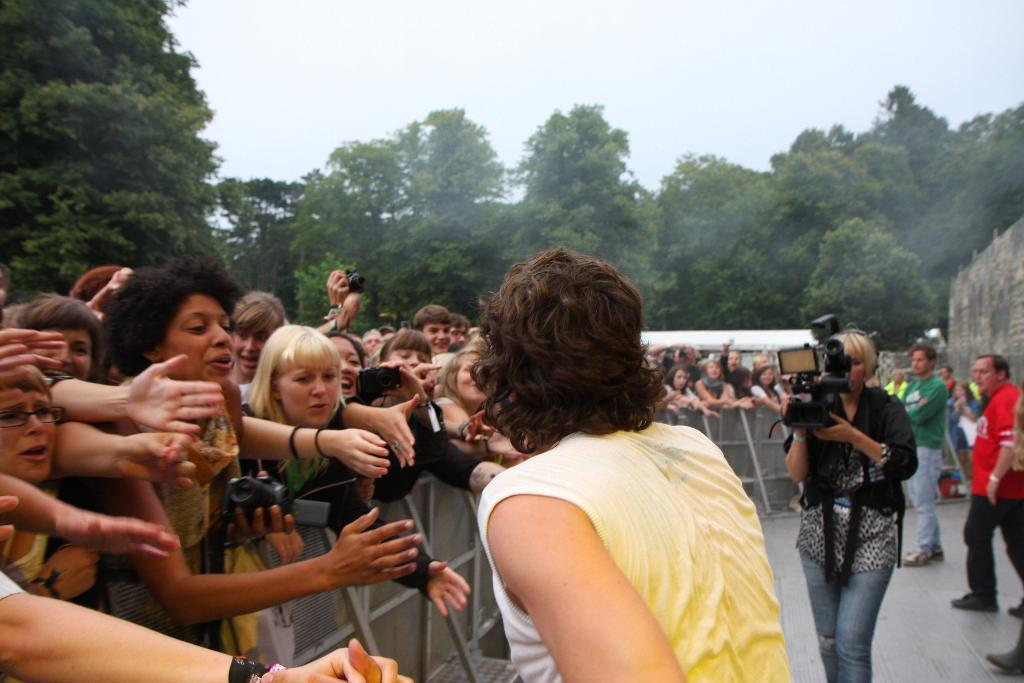How many people are in the image? There is a group of people in the image, but the exact number cannot be determined from the provided facts. Where are some of the people located in the image? Some of the people are standing near the fencing in the image. What are some people doing in the image? Some people are holding cameras in the image. What can be seen in the background of the image? There are trees, a wall, and a tent in the background of the image. What is visible at the top of the image? The sky is visible at the top of the image. How many pages of paper can be seen in the image? There is no paper visible in the image. What is the increase in temperature in the image? The provided facts do not mention any temperature changes or measurements in the image. 